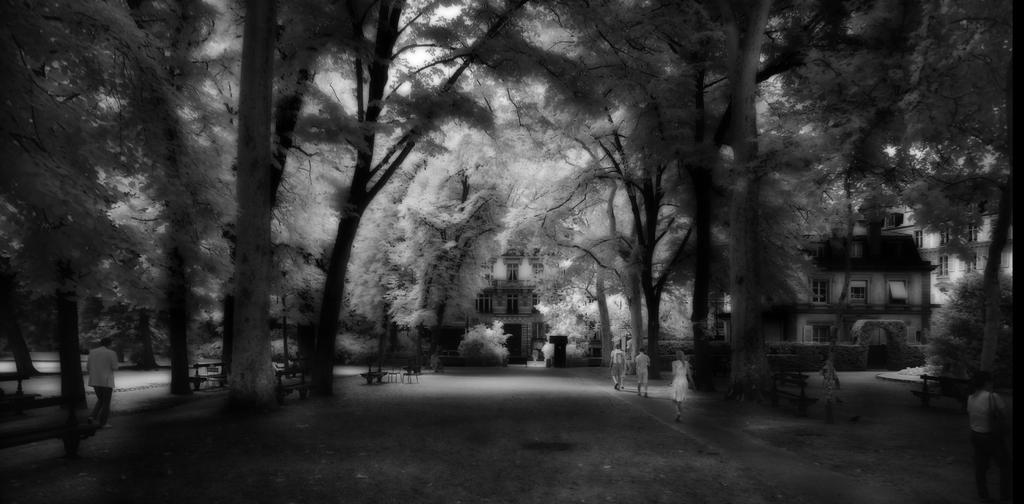What is the color scheme of the image? The image is in black and white. What type of natural elements can be seen on the ground? There are trees on the ground. What are the people in the image doing? There are people walking in the image. What type of structures can be seen in the background? There are buildings in the background. What type of seating is available on the ground? There are benches on the ground. Can you hear the bats laughing in the image? There are no bats or sounds present in the image, as it is a black and white image featuring trees, people walking, buildings, and benches. 